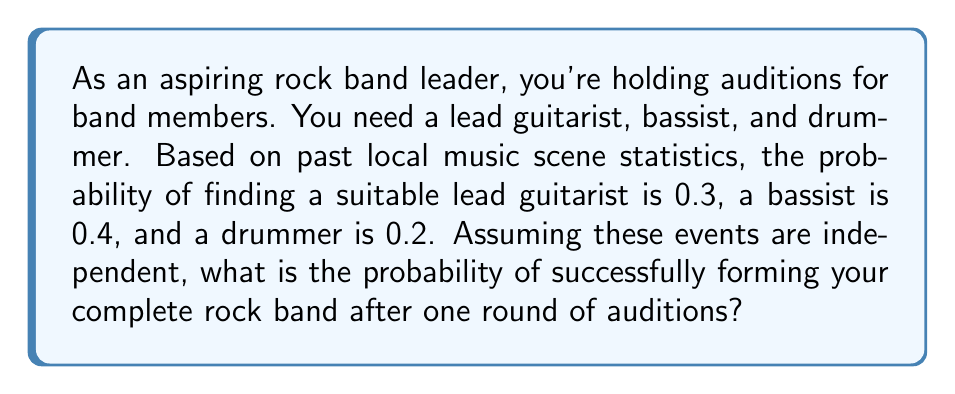Can you answer this question? To solve this problem, we need to use the concept of independent events and probability multiplication.

1) For independent events, the probability of all events occurring is the product of their individual probabilities.

2) Let's define our events:
   A: Finding a suitable lead guitarist (P(A) = 0.3)
   B: Finding a suitable bassist (P(B) = 0.4)
   C: Finding a suitable drummer (P(C) = 0.2)

3) We want to find P(A and B and C)

4) Since these events are independent:

   $$P(A \text{ and } B \text{ and } C) = P(A) \times P(B) \times P(C)$$

5) Substituting the given probabilities:

   $$P(A \text{ and } B \text{ and } C) = 0.3 \times 0.4 \times 0.2$$

6) Calculating:

   $$P(A \text{ and } B \text{ and } C) = 0.024$$

7) Converting to a percentage:

   $$0.024 \times 100\% = 2.4\%$$

Therefore, the probability of successfully forming your complete rock band after one round of auditions is 2.4%.
Answer: $0.024$ or $2.4\%$ 